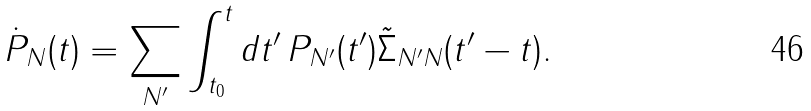Convert formula to latex. <formula><loc_0><loc_0><loc_500><loc_500>\dot { P } _ { N } ( t ) = \sum _ { N ^ { \prime } } \int ^ { t } _ { t _ { 0 } } d t ^ { \prime } \, P _ { N ^ { \prime } } ( t ^ { \prime } ) \tilde { \Sigma } _ { N ^ { \prime } N } ( t ^ { \prime } - t ) .</formula> 